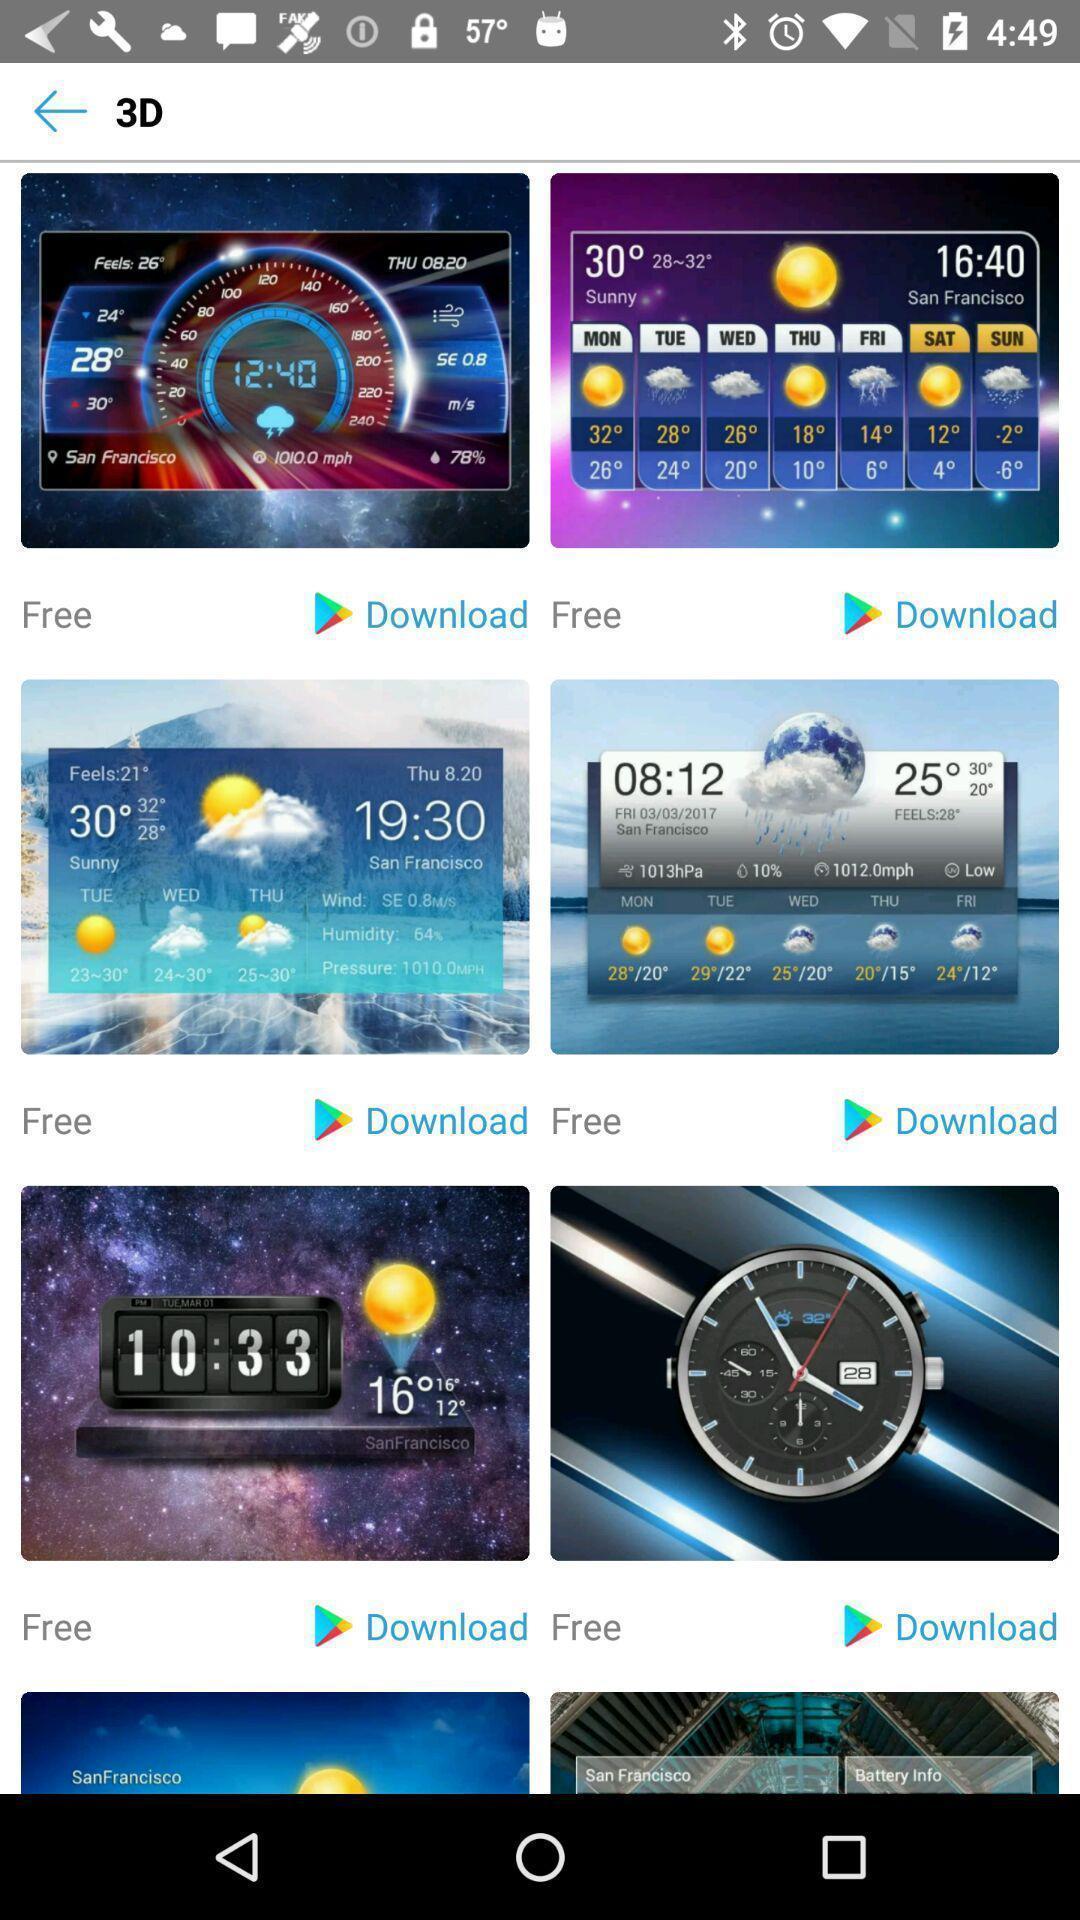Provide a textual representation of this image. Screen showing 3d images to download. 